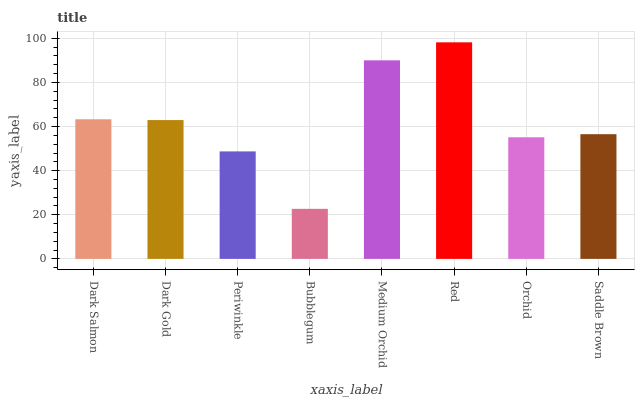Is Bubblegum the minimum?
Answer yes or no. Yes. Is Red the maximum?
Answer yes or no. Yes. Is Dark Gold the minimum?
Answer yes or no. No. Is Dark Gold the maximum?
Answer yes or no. No. Is Dark Salmon greater than Dark Gold?
Answer yes or no. Yes. Is Dark Gold less than Dark Salmon?
Answer yes or no. Yes. Is Dark Gold greater than Dark Salmon?
Answer yes or no. No. Is Dark Salmon less than Dark Gold?
Answer yes or no. No. Is Dark Gold the high median?
Answer yes or no. Yes. Is Saddle Brown the low median?
Answer yes or no. Yes. Is Orchid the high median?
Answer yes or no. No. Is Dark Salmon the low median?
Answer yes or no. No. 